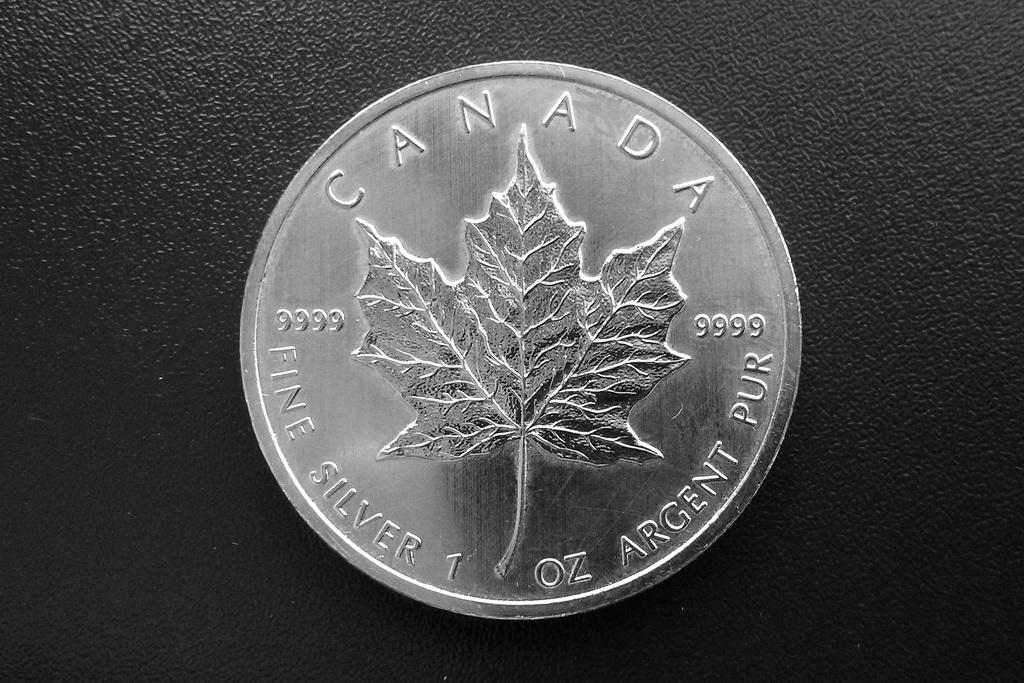Provide a one-sentence caption for the provided image. A canadian coin sitting on a black background. 